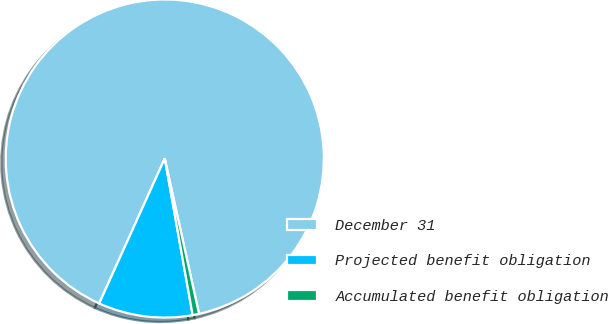Convert chart to OTSL. <chart><loc_0><loc_0><loc_500><loc_500><pie_chart><fcel>December 31<fcel>Projected benefit obligation<fcel>Accumulated benefit obligation<nl><fcel>89.78%<fcel>9.57%<fcel>0.65%<nl></chart> 